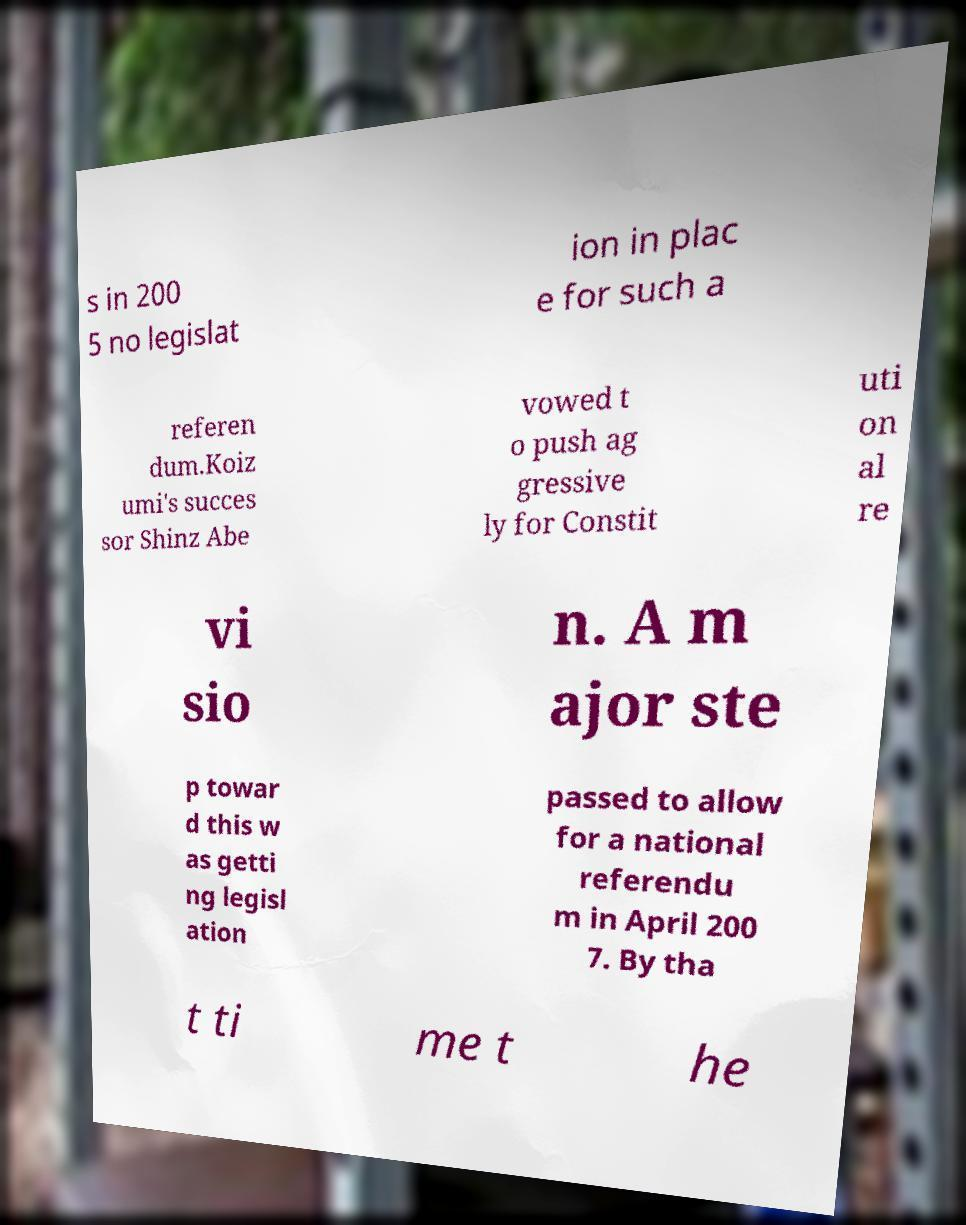Could you extract and type out the text from this image? s in 200 5 no legislat ion in plac e for such a referen dum.Koiz umi's succes sor Shinz Abe vowed t o push ag gressive ly for Constit uti on al re vi sio n. A m ajor ste p towar d this w as getti ng legisl ation passed to allow for a national referendu m in April 200 7. By tha t ti me t he 